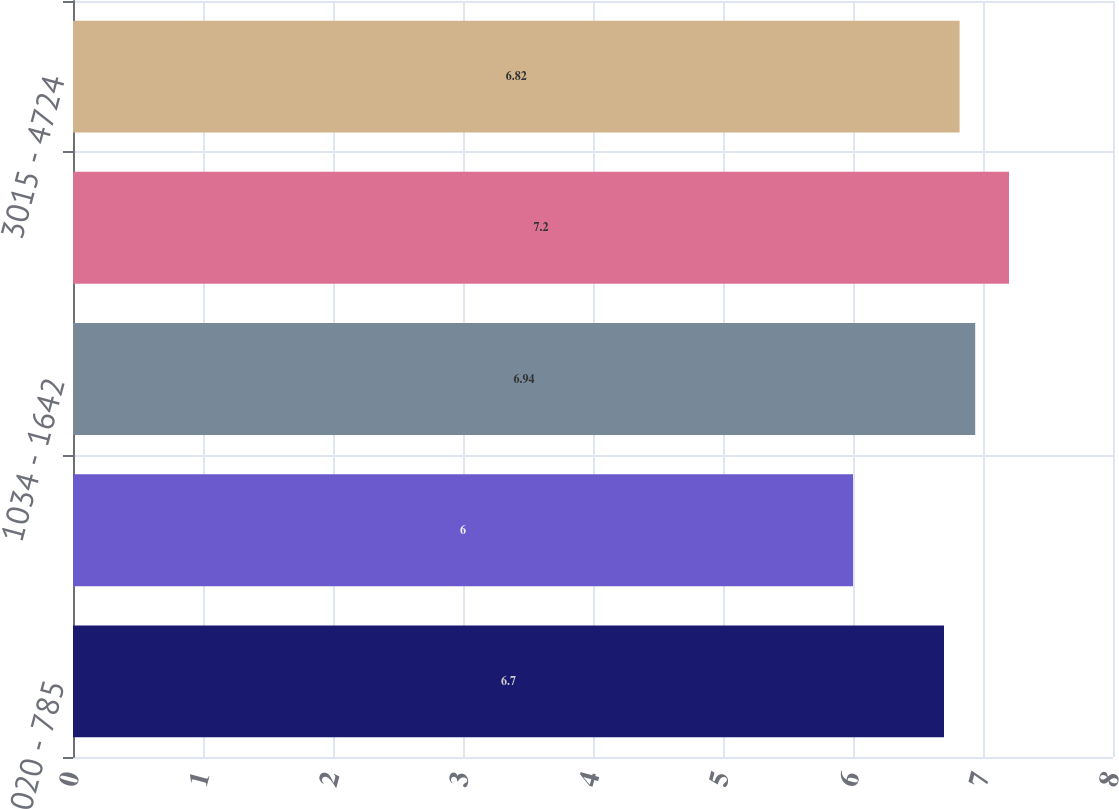Convert chart to OTSL. <chart><loc_0><loc_0><loc_500><loc_500><bar_chart><fcel>020 - 785<fcel>787 - 1025<fcel>1034 - 1642<fcel>1736 - 2937<fcel>3015 - 4724<nl><fcel>6.7<fcel>6<fcel>6.94<fcel>7.2<fcel>6.82<nl></chart> 